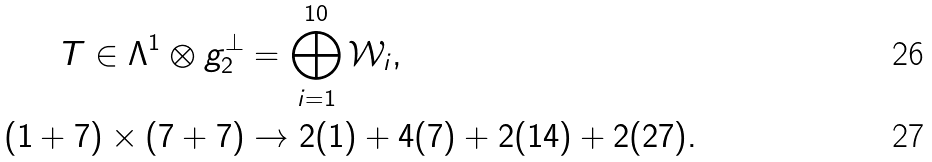<formula> <loc_0><loc_0><loc_500><loc_500>T \in \Lambda ^ { 1 } \otimes g _ { 2 } ^ { \perp } & = \bigoplus _ { i = 1 } ^ { 1 0 } \mathcal { W } _ { i } , \\ ( 1 + 7 ) \times ( 7 + 7 ) & \to 2 ( 1 ) + 4 ( 7 ) + 2 ( 1 4 ) + 2 ( 2 7 ) .</formula> 